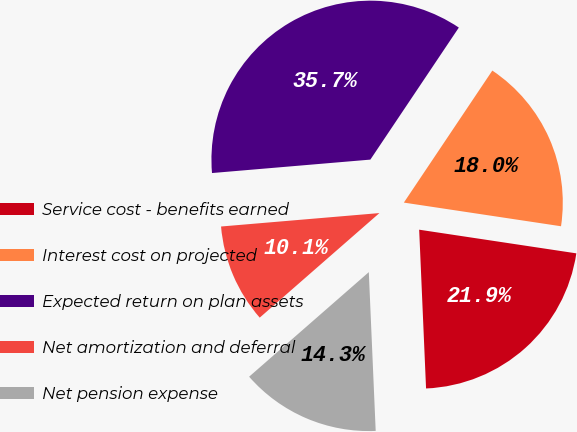Convert chart. <chart><loc_0><loc_0><loc_500><loc_500><pie_chart><fcel>Service cost - benefits earned<fcel>Interest cost on projected<fcel>Expected return on plan assets<fcel>Net amortization and deferral<fcel>Net pension expense<nl><fcel>21.93%<fcel>17.98%<fcel>35.74%<fcel>10.08%<fcel>14.26%<nl></chart> 